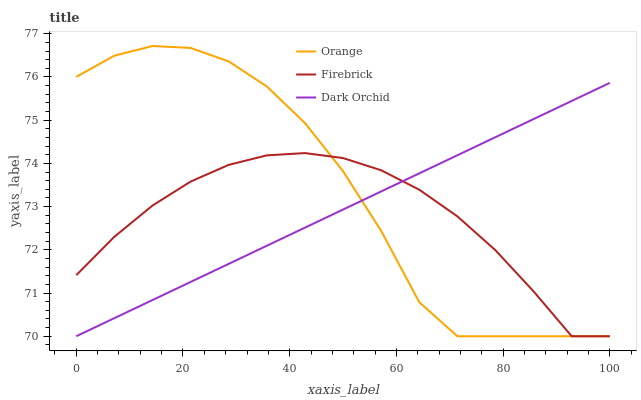Does Firebrick have the minimum area under the curve?
Answer yes or no. Yes. Does Orange have the maximum area under the curve?
Answer yes or no. Yes. Does Dark Orchid have the minimum area under the curve?
Answer yes or no. No. Does Dark Orchid have the maximum area under the curve?
Answer yes or no. No. Is Dark Orchid the smoothest?
Answer yes or no. Yes. Is Orange the roughest?
Answer yes or no. Yes. Is Firebrick the smoothest?
Answer yes or no. No. Is Firebrick the roughest?
Answer yes or no. No. Does Orange have the lowest value?
Answer yes or no. Yes. Does Orange have the highest value?
Answer yes or no. Yes. Does Dark Orchid have the highest value?
Answer yes or no. No. Does Firebrick intersect Orange?
Answer yes or no. Yes. Is Firebrick less than Orange?
Answer yes or no. No. Is Firebrick greater than Orange?
Answer yes or no. No. 